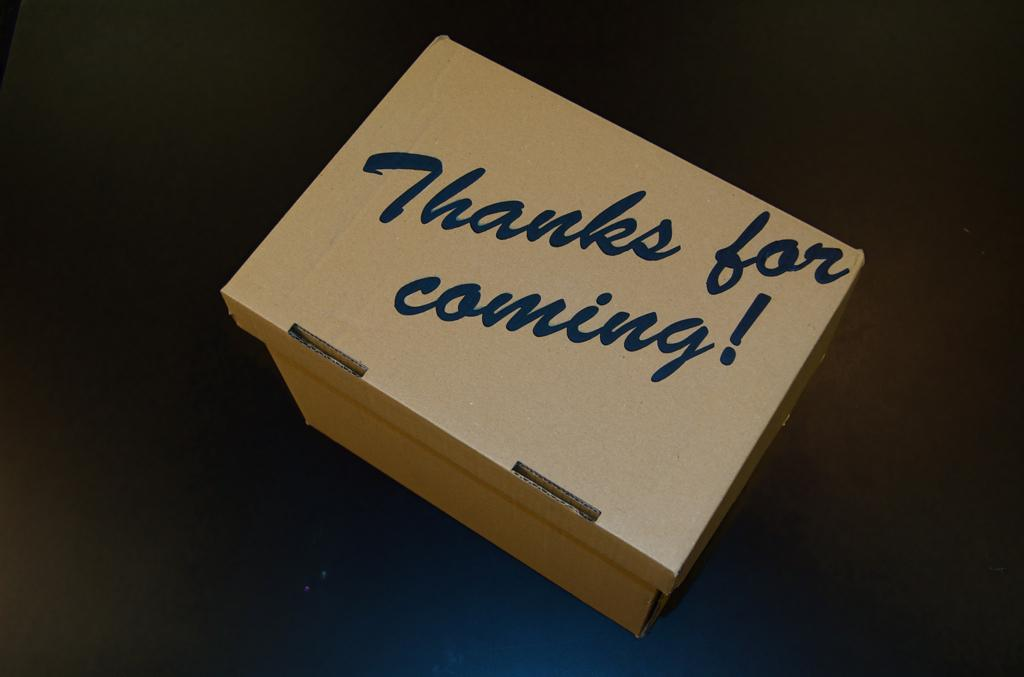<image>
Share a concise interpretation of the image provided. a box on the ground with blue cursive lettering on it that says 'thanks for coming!' 